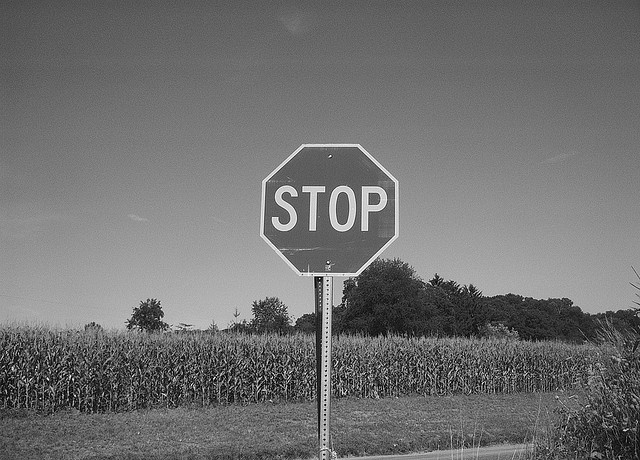Describe the objects in this image and their specific colors. I can see a stop sign in gray, lightgray, darkgray, and black tones in this image. 